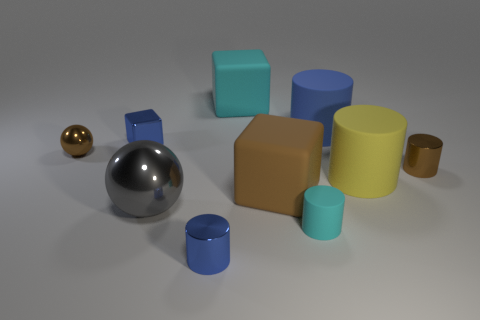There is a cyan object that is in front of the big shiny object; what is its material?
Your answer should be compact. Rubber. The shiny object that is right of the big rubber cylinder that is to the left of the yellow cylinder that is on the left side of the brown metallic cylinder is what color?
Offer a very short reply. Brown. There is a cube that is the same size as the brown cylinder; what color is it?
Your answer should be very brief. Blue. How many matte things are either small objects or tiny brown objects?
Provide a succinct answer. 1. The block that is the same material as the small ball is what color?
Offer a very short reply. Blue. What material is the blue cylinder that is behind the metal object that is on the right side of the cyan cube?
Offer a terse response. Rubber. What number of objects are big cubes that are behind the large blue cylinder or cyan things that are in front of the gray metallic thing?
Keep it short and to the point. 2. What is the size of the brown metallic ball that is in front of the metallic block that is left of the tiny brown object that is on the right side of the tiny brown metal sphere?
Ensure brevity in your answer.  Small. Are there an equal number of large matte cylinders that are in front of the small blue block and tiny blue cylinders?
Provide a short and direct response. Yes. There is a yellow matte thing; does it have the same shape as the large thing on the left side of the cyan block?
Provide a succinct answer. No. 